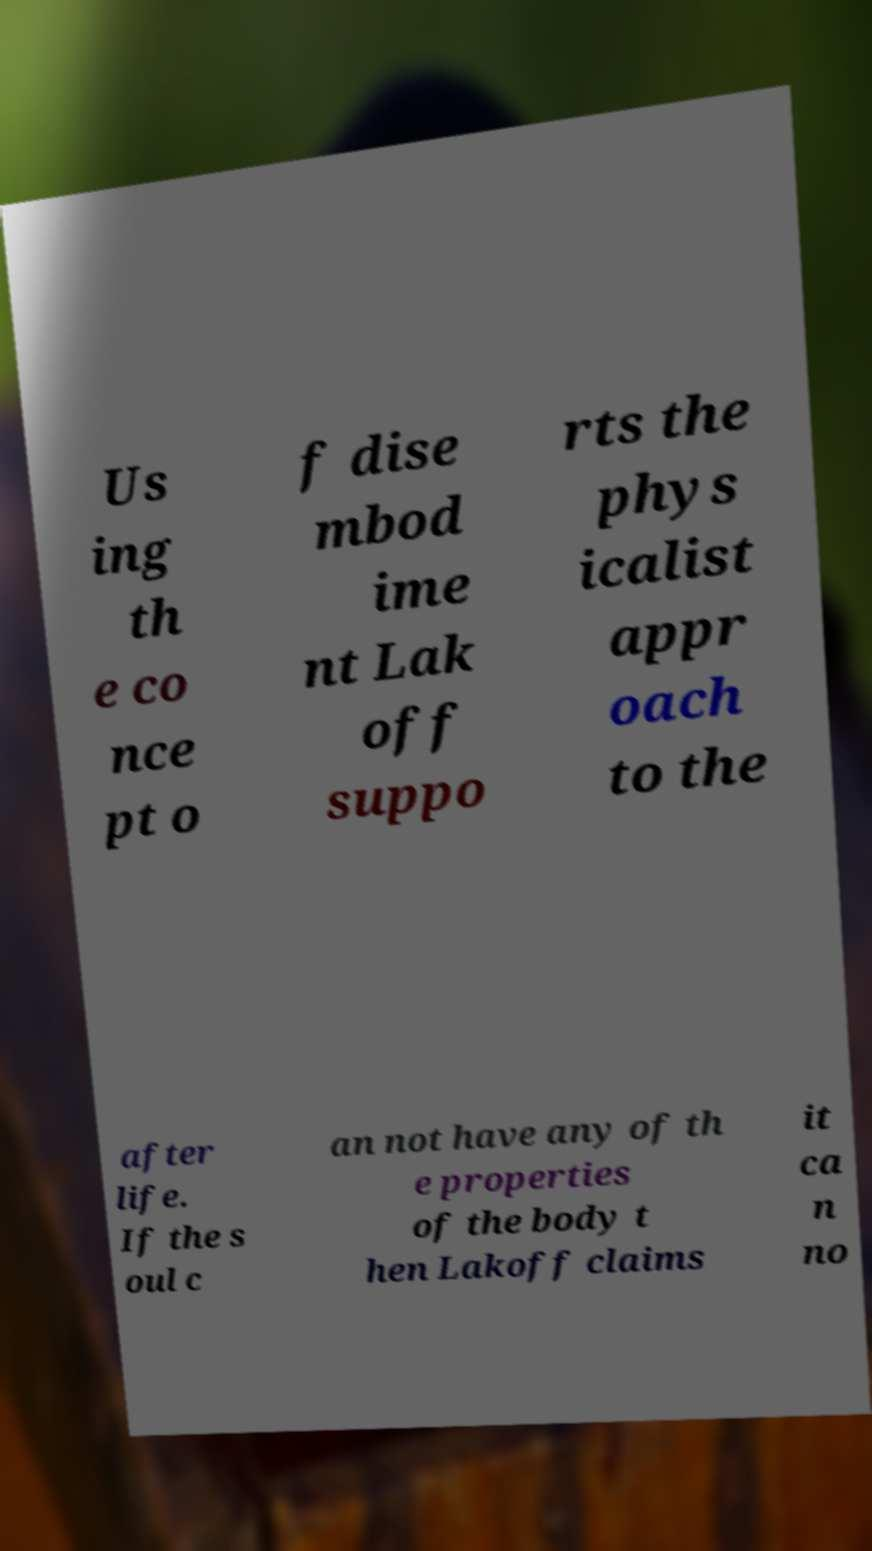Could you assist in decoding the text presented in this image and type it out clearly? Us ing th e co nce pt o f dise mbod ime nt Lak off suppo rts the phys icalist appr oach to the after life. If the s oul c an not have any of th e properties of the body t hen Lakoff claims it ca n no 